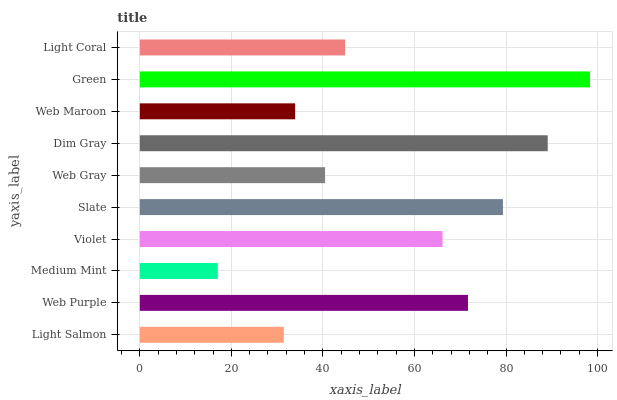Is Medium Mint the minimum?
Answer yes or no. Yes. Is Green the maximum?
Answer yes or no. Yes. Is Web Purple the minimum?
Answer yes or no. No. Is Web Purple the maximum?
Answer yes or no. No. Is Web Purple greater than Light Salmon?
Answer yes or no. Yes. Is Light Salmon less than Web Purple?
Answer yes or no. Yes. Is Light Salmon greater than Web Purple?
Answer yes or no. No. Is Web Purple less than Light Salmon?
Answer yes or no. No. Is Violet the high median?
Answer yes or no. Yes. Is Light Coral the low median?
Answer yes or no. Yes. Is Web Gray the high median?
Answer yes or no. No. Is Violet the low median?
Answer yes or no. No. 